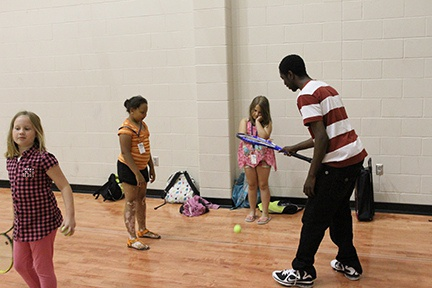Describe the objects in this image and their specific colors. I can see people in lightgray, black, maroon, and darkgray tones, people in lightgray, black, brown, and maroon tones, people in lightgray, maroon, black, and brown tones, people in lightgray, brown, maroon, and black tones, and backpack in lightgray, black, darkgray, and gray tones in this image. 